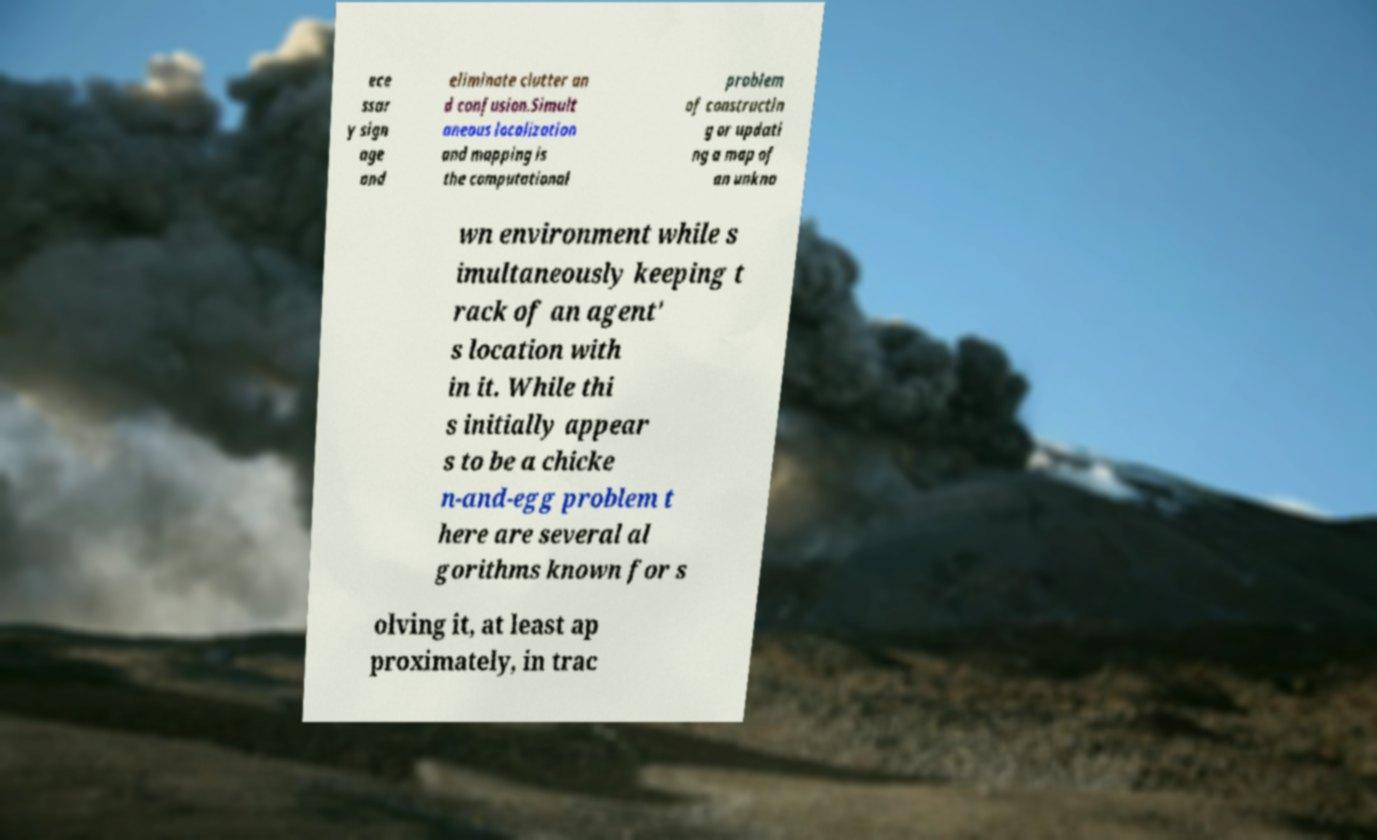There's text embedded in this image that I need extracted. Can you transcribe it verbatim? ece ssar y sign age and eliminate clutter an d confusion.Simult aneous localization and mapping is the computational problem of constructin g or updati ng a map of an unkno wn environment while s imultaneously keeping t rack of an agent' s location with in it. While thi s initially appear s to be a chicke n-and-egg problem t here are several al gorithms known for s olving it, at least ap proximately, in trac 